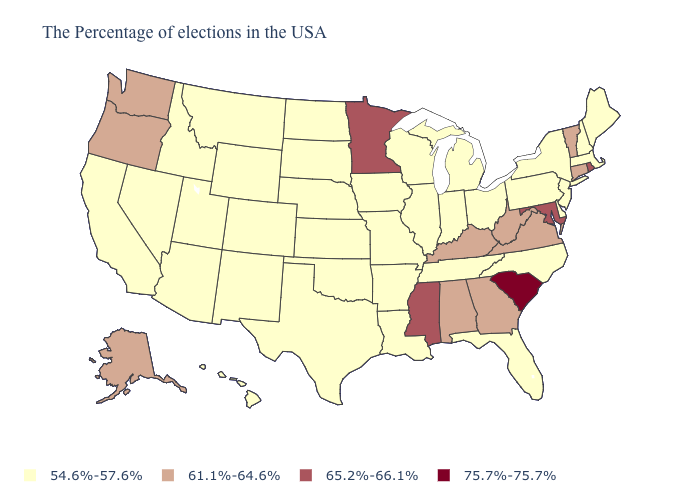Does Virginia have the lowest value in the USA?
Quick response, please. No. How many symbols are there in the legend?
Give a very brief answer. 4. Name the states that have a value in the range 61.1%-64.6%?
Be succinct. Vermont, Connecticut, Virginia, West Virginia, Georgia, Kentucky, Alabama, Washington, Oregon, Alaska. Name the states that have a value in the range 54.6%-57.6%?
Be succinct. Maine, Massachusetts, New Hampshire, New York, New Jersey, Delaware, Pennsylvania, North Carolina, Ohio, Florida, Michigan, Indiana, Tennessee, Wisconsin, Illinois, Louisiana, Missouri, Arkansas, Iowa, Kansas, Nebraska, Oklahoma, Texas, South Dakota, North Dakota, Wyoming, Colorado, New Mexico, Utah, Montana, Arizona, Idaho, Nevada, California, Hawaii. Which states have the lowest value in the South?
Answer briefly. Delaware, North Carolina, Florida, Tennessee, Louisiana, Arkansas, Oklahoma, Texas. What is the lowest value in the Northeast?
Write a very short answer. 54.6%-57.6%. What is the value of Iowa?
Write a very short answer. 54.6%-57.6%. What is the value of Colorado?
Concise answer only. 54.6%-57.6%. Does Kansas have a higher value than Texas?
Write a very short answer. No. What is the highest value in the USA?
Short answer required. 75.7%-75.7%. Does the first symbol in the legend represent the smallest category?
Keep it brief. Yes. Does the map have missing data?
Write a very short answer. No. Name the states that have a value in the range 65.2%-66.1%?
Write a very short answer. Rhode Island, Maryland, Mississippi, Minnesota. Name the states that have a value in the range 75.7%-75.7%?
Concise answer only. South Carolina. 